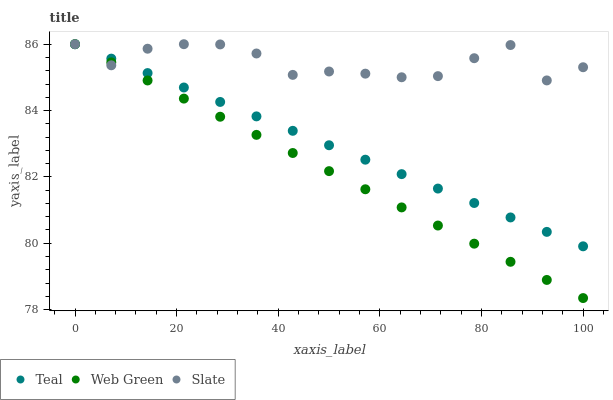Does Web Green have the minimum area under the curve?
Answer yes or no. Yes. Does Slate have the maximum area under the curve?
Answer yes or no. Yes. Does Teal have the minimum area under the curve?
Answer yes or no. No. Does Teal have the maximum area under the curve?
Answer yes or no. No. Is Teal the smoothest?
Answer yes or no. Yes. Is Slate the roughest?
Answer yes or no. Yes. Is Web Green the smoothest?
Answer yes or no. No. Is Web Green the roughest?
Answer yes or no. No. Does Web Green have the lowest value?
Answer yes or no. Yes. Does Teal have the lowest value?
Answer yes or no. No. Does Teal have the highest value?
Answer yes or no. Yes. Does Slate intersect Teal?
Answer yes or no. Yes. Is Slate less than Teal?
Answer yes or no. No. Is Slate greater than Teal?
Answer yes or no. No. 